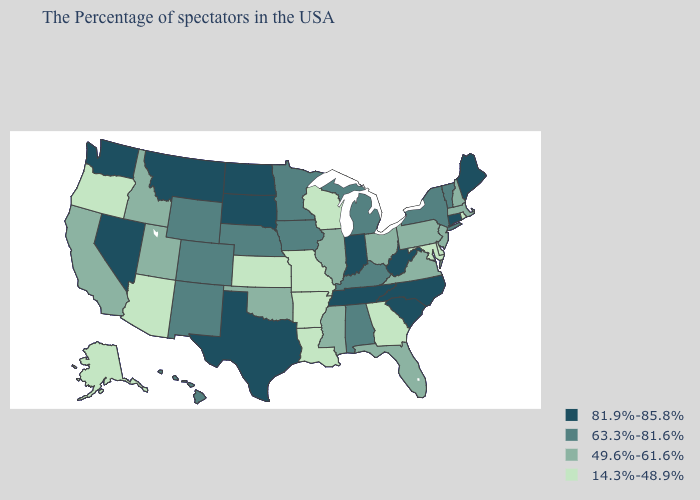Does Delaware have a lower value than New Mexico?
Quick response, please. Yes. What is the value of Hawaii?
Be succinct. 63.3%-81.6%. What is the value of Wisconsin?
Write a very short answer. 14.3%-48.9%. Among the states that border Rhode Island , does Connecticut have the highest value?
Be succinct. Yes. How many symbols are there in the legend?
Concise answer only. 4. What is the highest value in the USA?
Answer briefly. 81.9%-85.8%. Does Louisiana have the lowest value in the USA?
Write a very short answer. Yes. Among the states that border Arkansas , which have the lowest value?
Answer briefly. Louisiana, Missouri. Is the legend a continuous bar?
Write a very short answer. No. Does Ohio have the lowest value in the USA?
Write a very short answer. No. Is the legend a continuous bar?
Quick response, please. No. Does Vermont have the lowest value in the Northeast?
Keep it brief. No. Does New Jersey have the same value as California?
Quick response, please. Yes. What is the highest value in the South ?
Answer briefly. 81.9%-85.8%. Does the map have missing data?
Answer briefly. No. 